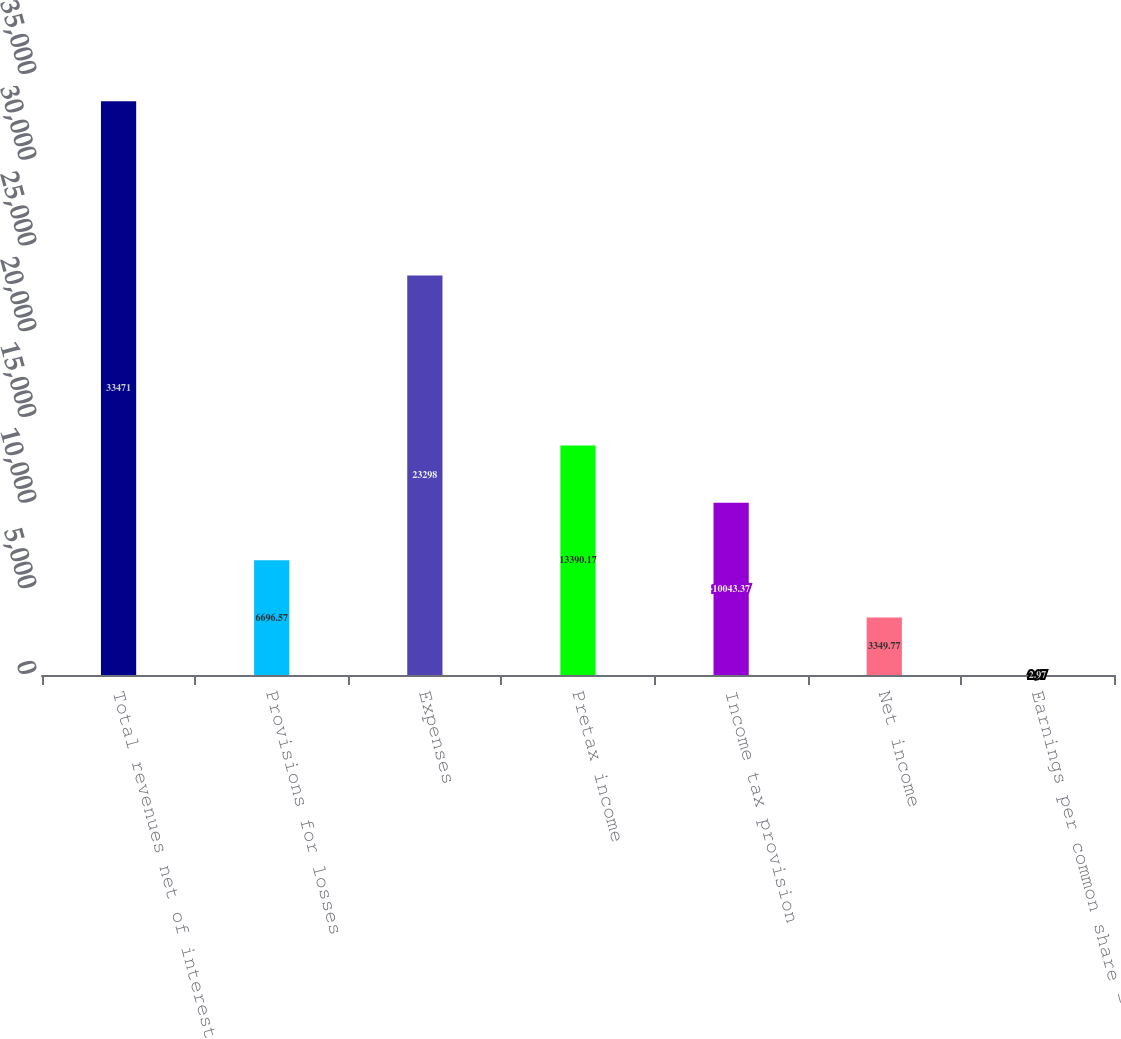<chart> <loc_0><loc_0><loc_500><loc_500><bar_chart><fcel>Total revenues net of interest<fcel>Provisions for losses<fcel>Expenses<fcel>Pretax income<fcel>Income tax provision<fcel>Net income<fcel>Earnings per common share -<nl><fcel>33471<fcel>6696.57<fcel>23298<fcel>13390.2<fcel>10043.4<fcel>3349.77<fcel>2.97<nl></chart> 